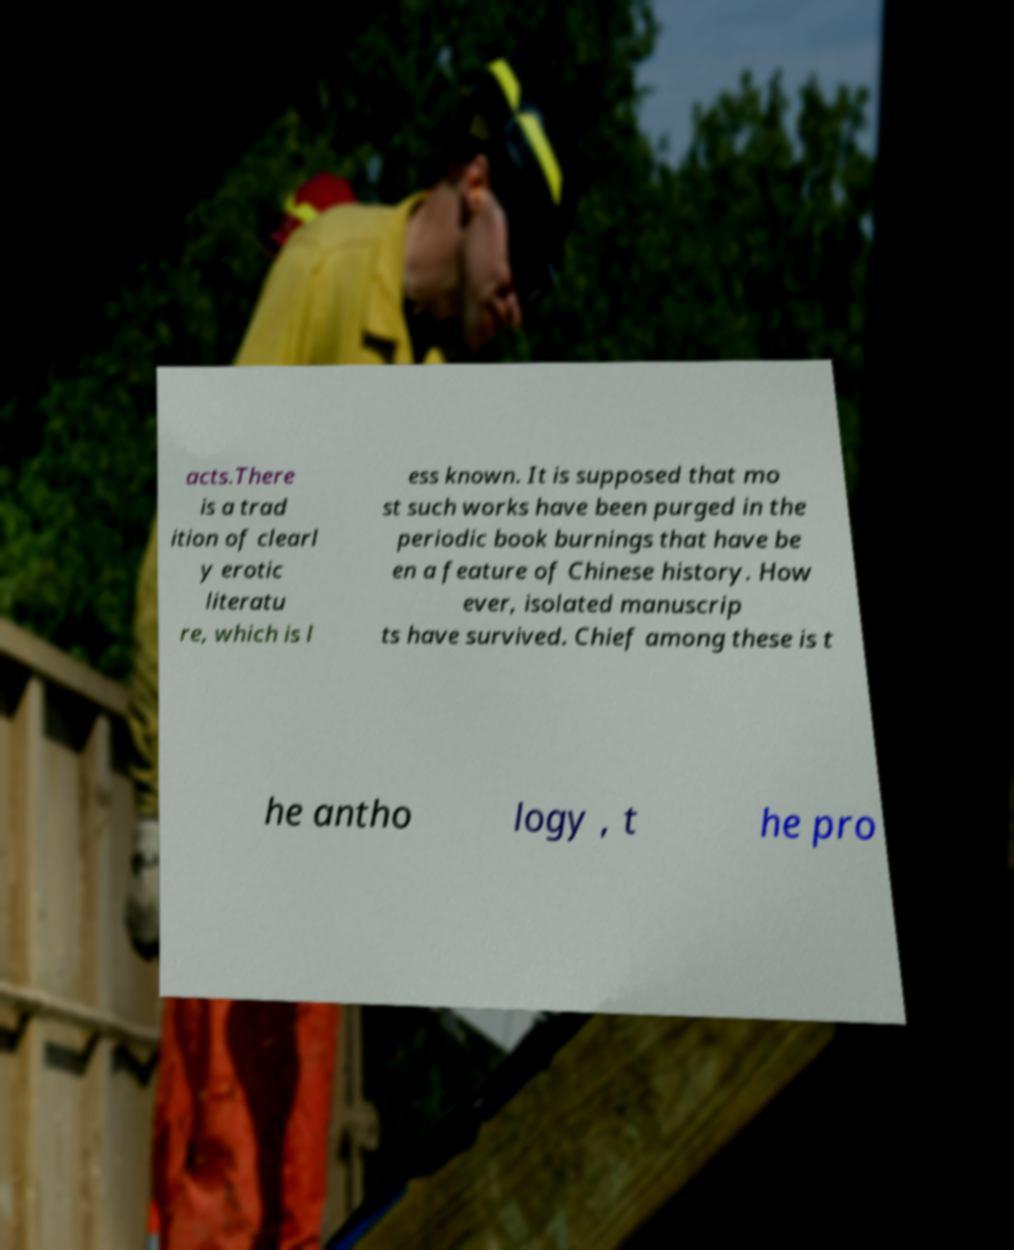What messages or text are displayed in this image? I need them in a readable, typed format. acts.There is a trad ition of clearl y erotic literatu re, which is l ess known. It is supposed that mo st such works have been purged in the periodic book burnings that have be en a feature of Chinese history. How ever, isolated manuscrip ts have survived. Chief among these is t he antho logy , t he pro 